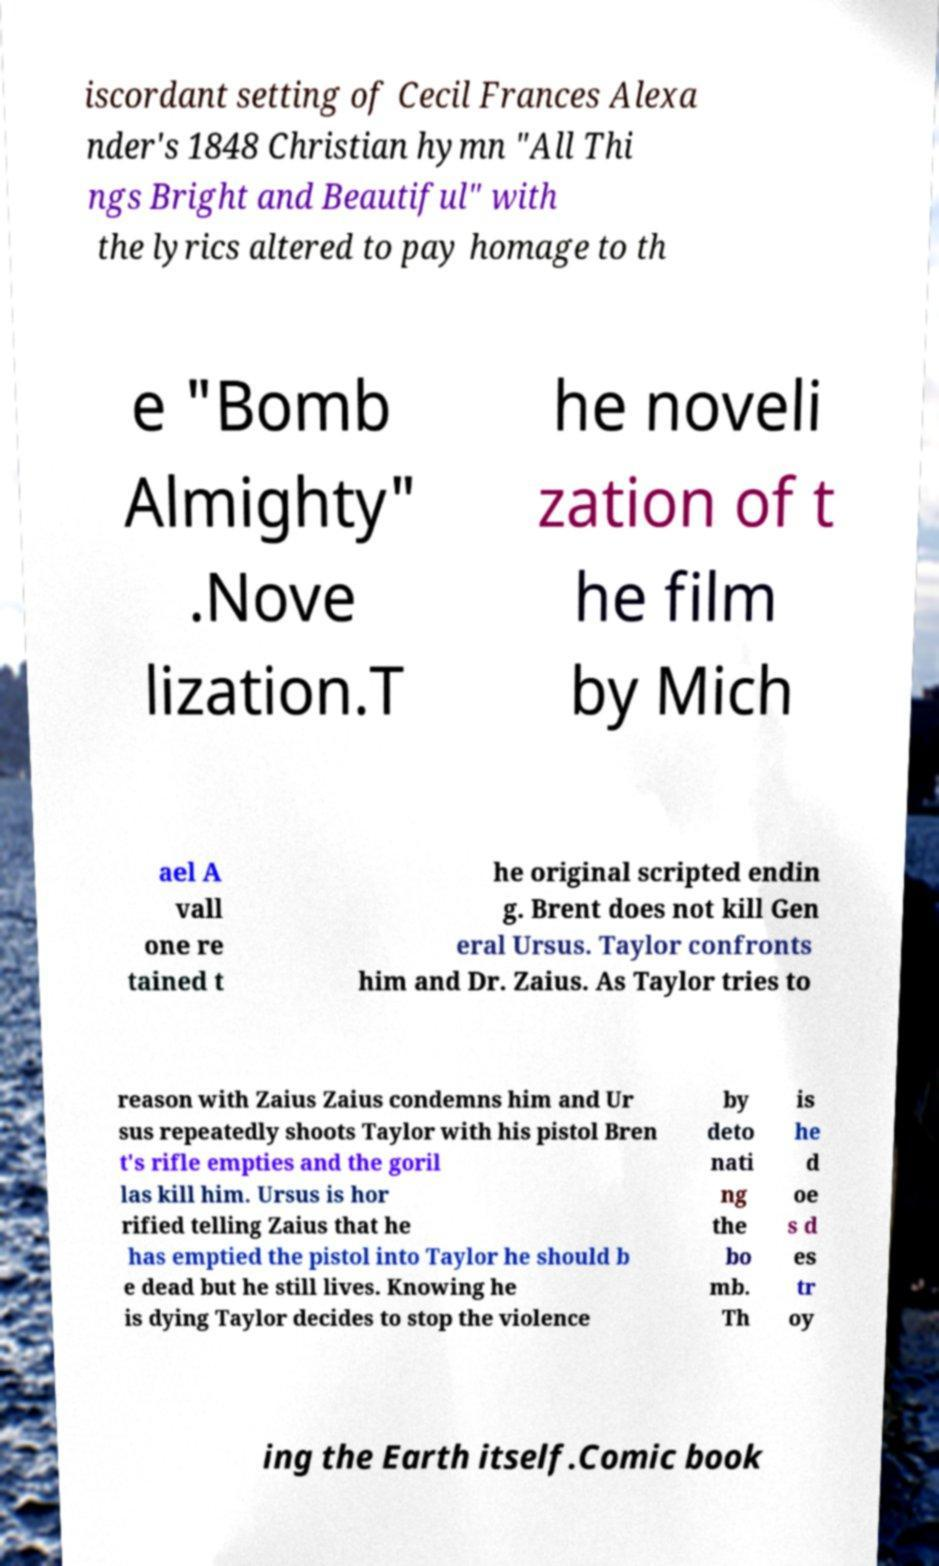Can you read and provide the text displayed in the image?This photo seems to have some interesting text. Can you extract and type it out for me? iscordant setting of Cecil Frances Alexa nder's 1848 Christian hymn "All Thi ngs Bright and Beautiful" with the lyrics altered to pay homage to th e "Bomb Almighty" .Nove lization.T he noveli zation of t he film by Mich ael A vall one re tained t he original scripted endin g. Brent does not kill Gen eral Ursus. Taylor confronts him and Dr. Zaius. As Taylor tries to reason with Zaius Zaius condemns him and Ur sus repeatedly shoots Taylor with his pistol Bren t's rifle empties and the goril las kill him. Ursus is hor rified telling Zaius that he has emptied the pistol into Taylor he should b e dead but he still lives. Knowing he is dying Taylor decides to stop the violence by deto nati ng the bo mb. Th is he d oe s d es tr oy ing the Earth itself.Comic book 